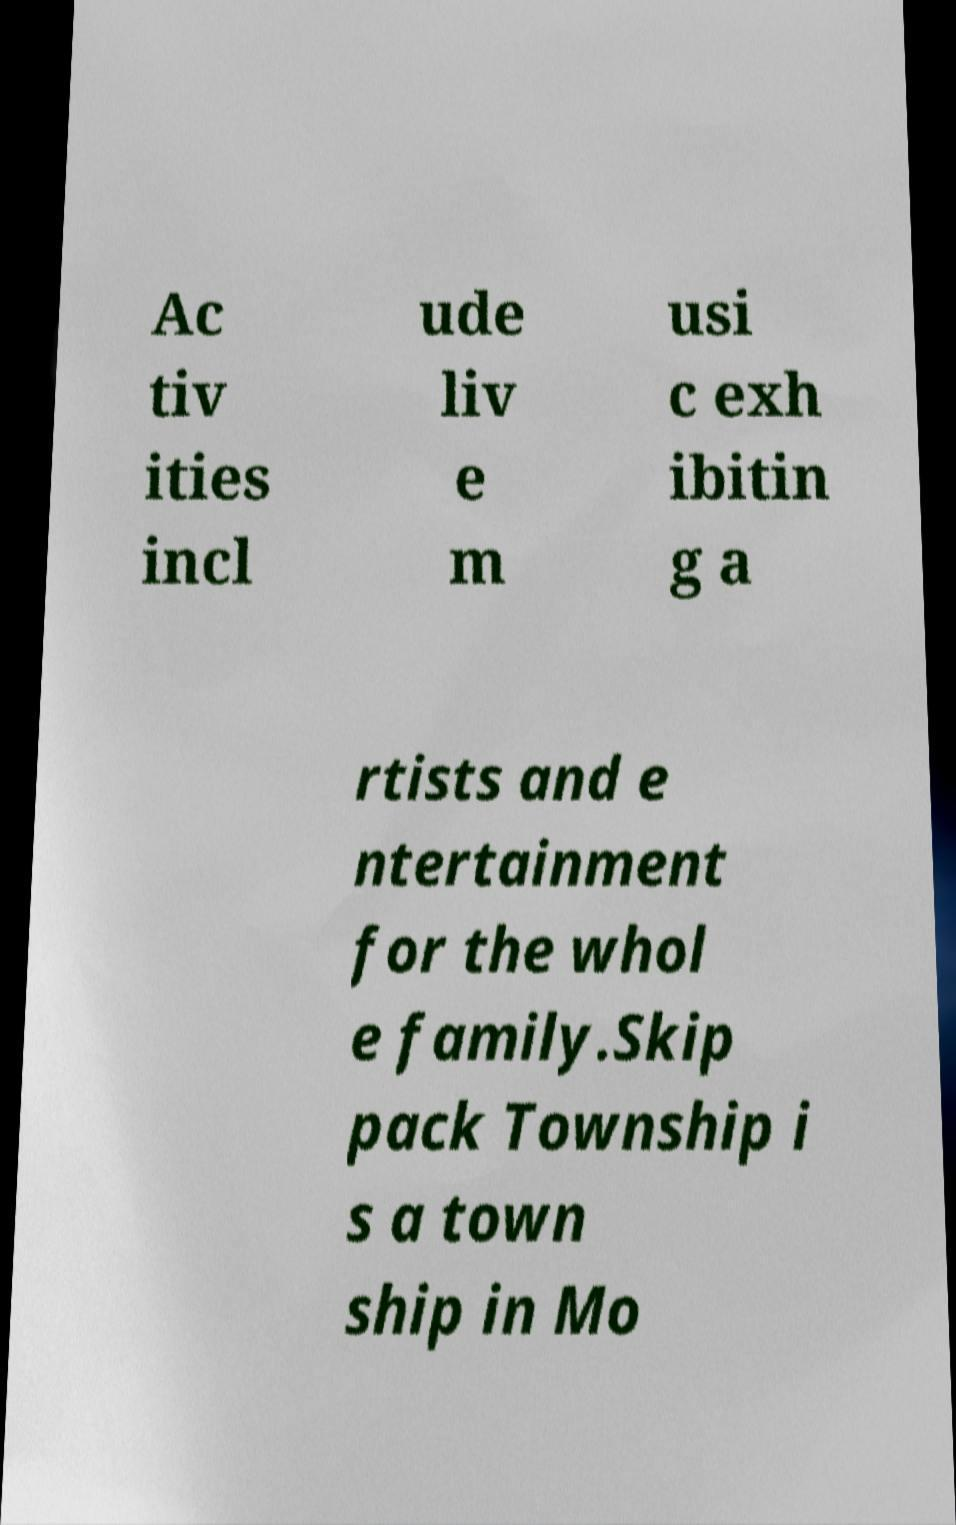I need the written content from this picture converted into text. Can you do that? Ac tiv ities incl ude liv e m usi c exh ibitin g a rtists and e ntertainment for the whol e family.Skip pack Township i s a town ship in Mo 